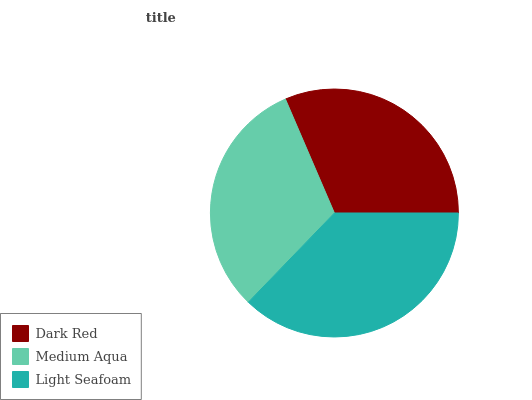Is Medium Aqua the minimum?
Answer yes or no. Yes. Is Light Seafoam the maximum?
Answer yes or no. Yes. Is Light Seafoam the minimum?
Answer yes or no. No. Is Medium Aqua the maximum?
Answer yes or no. No. Is Light Seafoam greater than Medium Aqua?
Answer yes or no. Yes. Is Medium Aqua less than Light Seafoam?
Answer yes or no. Yes. Is Medium Aqua greater than Light Seafoam?
Answer yes or no. No. Is Light Seafoam less than Medium Aqua?
Answer yes or no. No. Is Dark Red the high median?
Answer yes or no. Yes. Is Dark Red the low median?
Answer yes or no. Yes. Is Light Seafoam the high median?
Answer yes or no. No. Is Medium Aqua the low median?
Answer yes or no. No. 